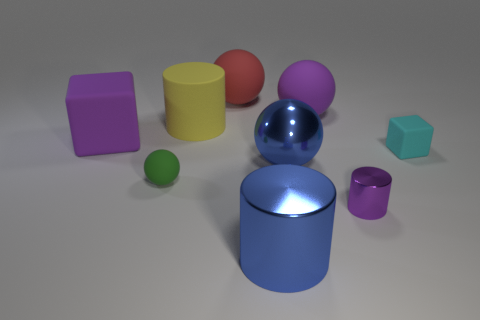What can you infer about the material of the teal cube? Based on the matte surface and lack of strong reflections, the teal cube appears to be made of a non-reflective, possibly rubber-like material. 